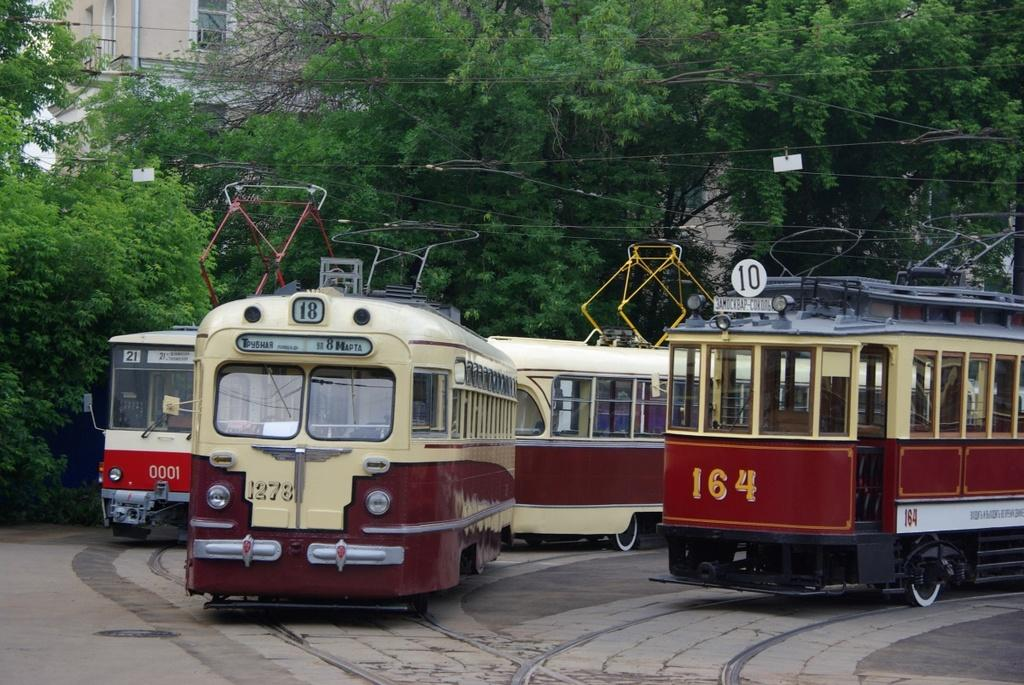What type of vehicles are present in the image? There are trams in the image. What can be seen written on the trams? There is text written on the trams. What type of natural elements are present in the image? There are trees in the image. What type of infrastructure is visible in the image? Electrical wires are visible in the image. What type of structure can be seen in the background of the image? There is a building in the background of the image. What architectural feature can be seen on the building? There are windows visible on the building. How many lizards are sitting on the trams in the image? There are no lizards present in the image; it features trams with text and trees, along with electrical wires and a building in the background. 